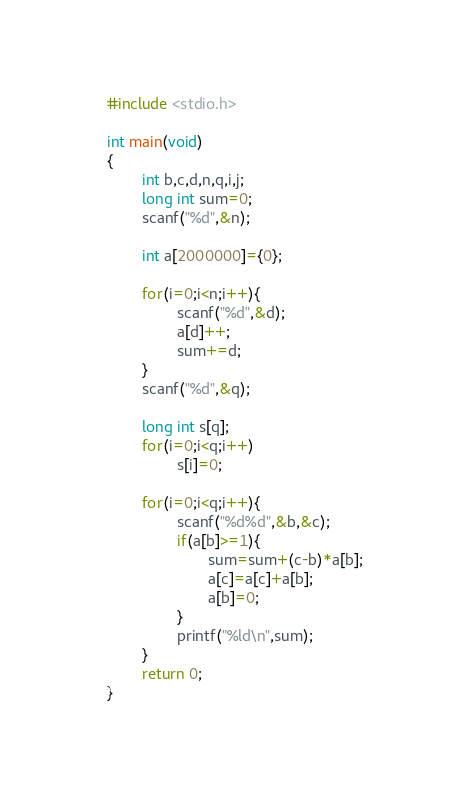Convert code to text. <code><loc_0><loc_0><loc_500><loc_500><_C_>#include <stdio.h>

int main(void)
{
        int b,c,d,n,q,i,j;
        long int sum=0;
        scanf("%d",&n);

        int a[2000000]={0};

        for(i=0;i<n;i++){
                scanf("%d",&d);
                a[d]++;
                sum+=d;
        }
        scanf("%d",&q);

        long int s[q];
        for(i=0;i<q;i++)
                s[i]=0;

        for(i=0;i<q;i++){
                scanf("%d%d",&b,&c);
                if(a[b]>=1){
                       sum=sum+(c-b)*a[b];
                       a[c]=a[c]+a[b];
                       a[b]=0;
                }
                printf("%ld\n",sum);
        }
        return 0;
}
</code> 